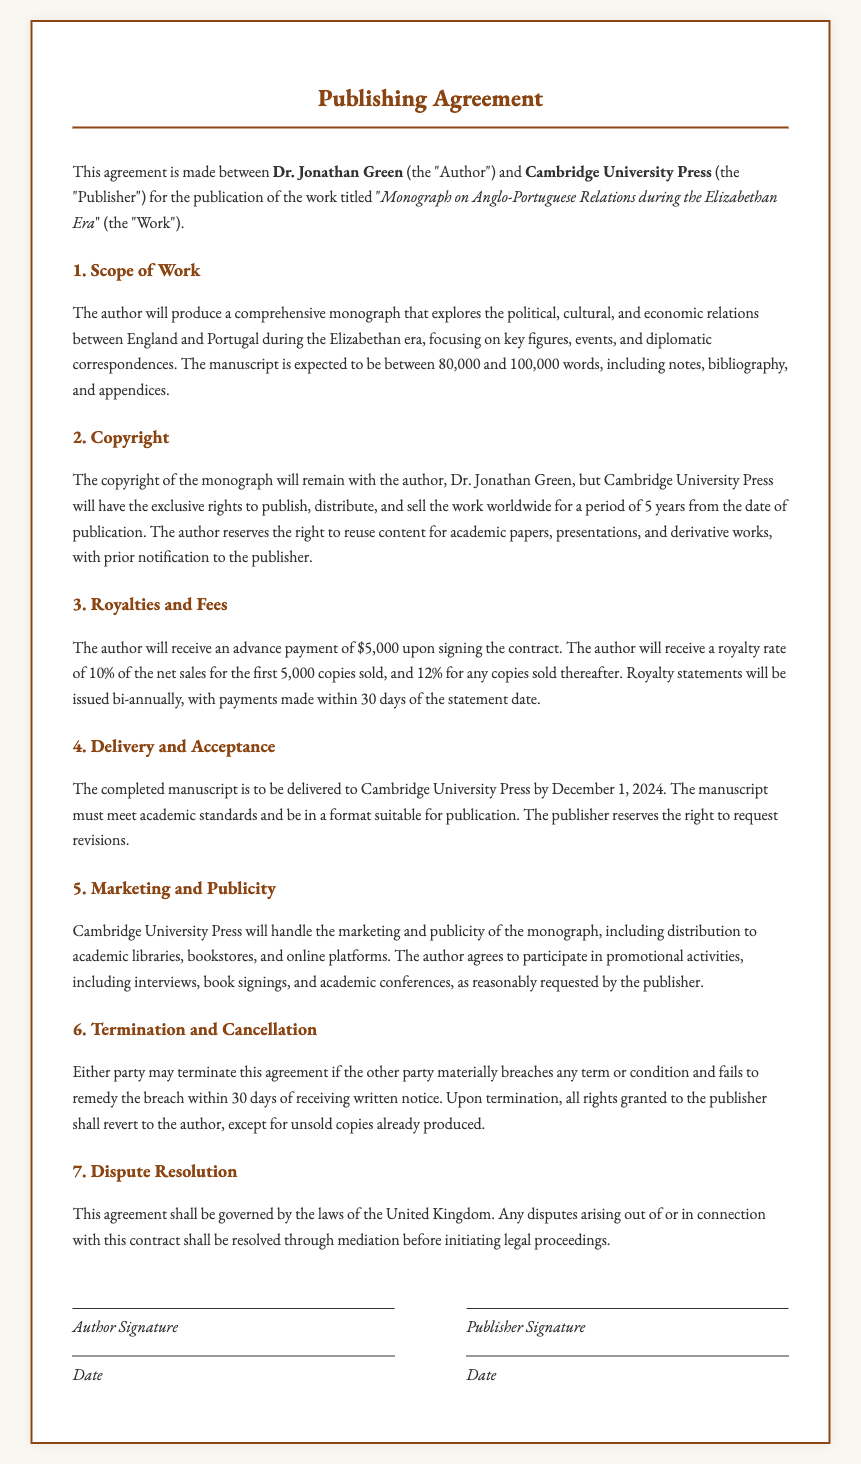What is the title of the work? The title of the work is explicitly provided in the document as the "Monograph on Anglo-Portuguese Relations during the Elizabethan Era."
Answer: Monograph on Anglo-Portuguese Relations during the Elizabethan Era Who is the author of the monograph? The author is named at the beginning of the agreement, identifying him as Dr. Jonathan Green.
Answer: Dr. Jonathan Green What is the duration of the exclusive publishing rights? The agreement states that the exclusive rights are valid for a period of 5 years from the date of publication.
Answer: 5 years What is the royalty rate for the first 5,000 copies sold? The document specifies a royalty rate of 10% for the first 5,000 copies sold.
Answer: 10% When is the completed manuscript due? The deadline for the completed manuscript is mentioned as December 1, 2024.
Answer: December 1, 2024 What must happen if either party breaches the agreement? The document indicates that upon a material breach, the non-breaching party must give written notice, and the breaching party has 30 days to remedy the breach.
Answer: 30 days What is the advance payment amount? The agreement indicates that the author will receive an advance payment of $5,000 upon signing the contract.
Answer: $5,000 Which publisher is involved in this agreement? The document identifies Cambridge University Press as the publisher for the monograph.
Answer: Cambridge University Press What actions must the author participate in regarding marketing? The author agrees to participate in promotional activities, including interviews, book signings, and academic conferences, as requested by the publisher.
Answer: promotional activities 